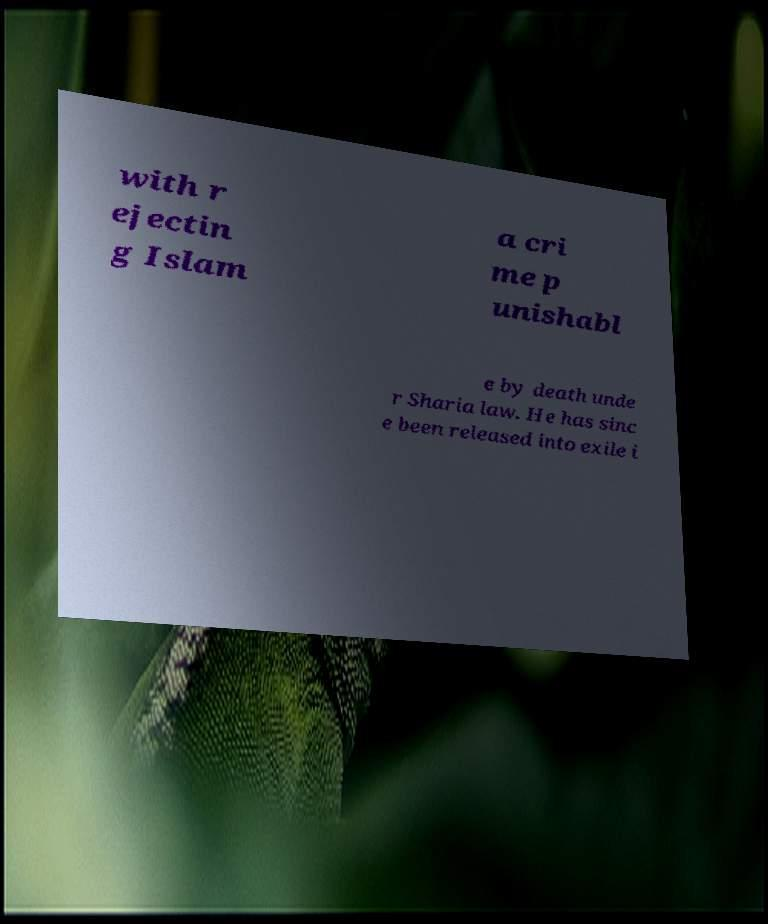Can you read and provide the text displayed in the image?This photo seems to have some interesting text. Can you extract and type it out for me? with r ejectin g Islam a cri me p unishabl e by death unde r Sharia law. He has sinc e been released into exile i 